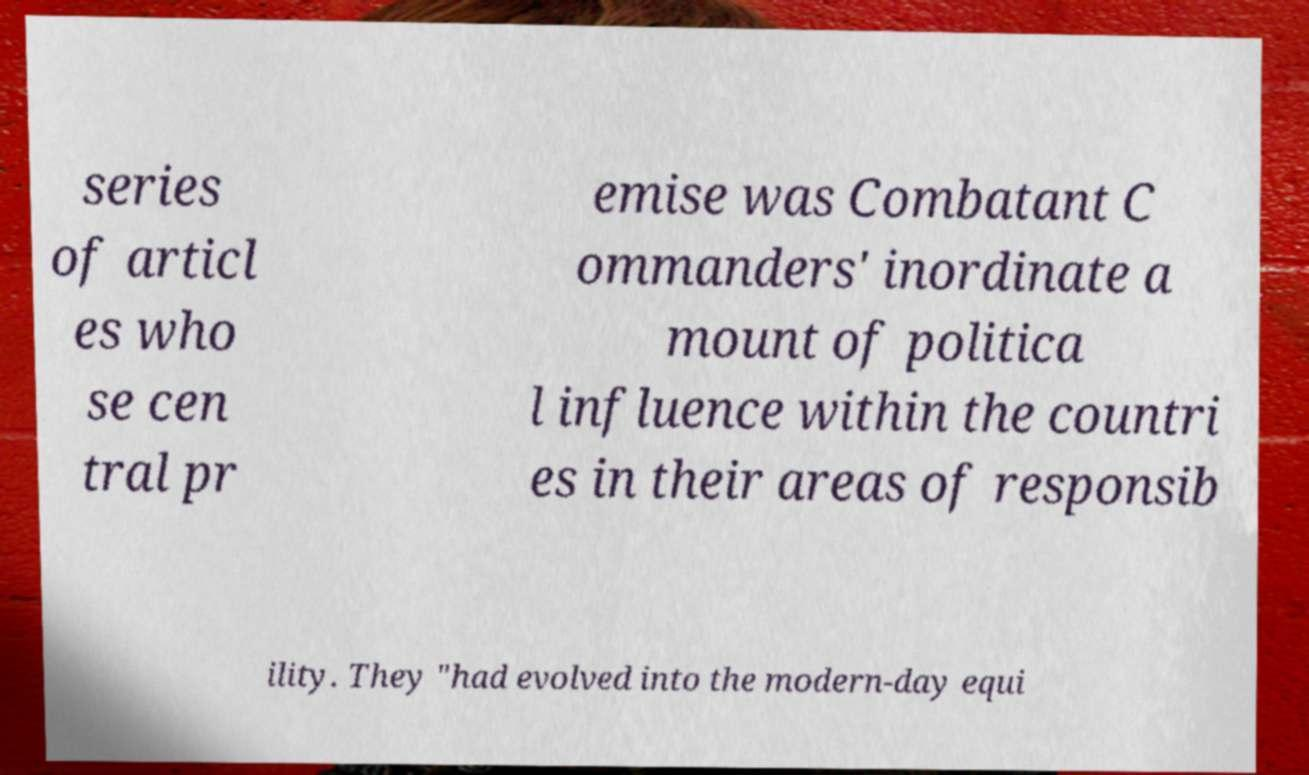Could you extract and type out the text from this image? series of articl es who se cen tral pr emise was Combatant C ommanders' inordinate a mount of politica l influence within the countri es in their areas of responsib ility. They "had evolved into the modern-day equi 